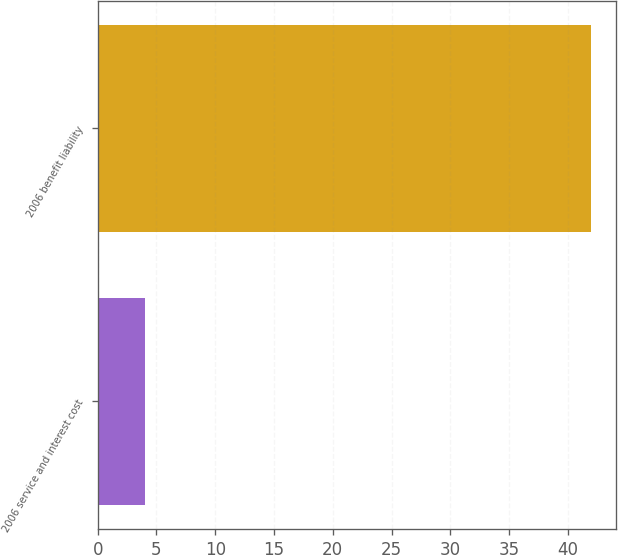Convert chart. <chart><loc_0><loc_0><loc_500><loc_500><bar_chart><fcel>2006 service and interest cost<fcel>2006 benefit liability<nl><fcel>4<fcel>42<nl></chart> 